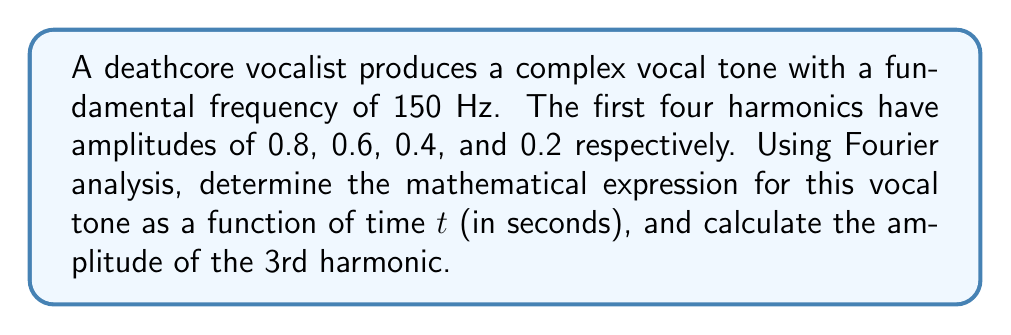Give your solution to this math problem. Let's approach this step-by-step:

1) In Fourier analysis, a complex tone can be represented as a sum of sine waves with different frequencies and amplitudes. The general form is:

   $$f(t) = \sum_{n=1}^{\infty} A_n \sin(2\pi n f_0 t)$$

   where $A_n$ is the amplitude of the nth harmonic, $f_0$ is the fundamental frequency, and $t$ is time.

2) We're given the fundamental frequency $f_0 = 150$ Hz and the amplitudes of the first four harmonics:
   
   $A_1 = 0.8$, $A_2 = 0.6$, $A_3 = 0.4$, $A_4 = 0.2$

3) Substituting these values into the general form:

   $$f(t) = 0.8 \sin(2\pi \cdot 150t) + 0.6 \sin(2\pi \cdot 300t) + 0.4 \sin(2\pi \cdot 450t) + 0.2 \sin(2\pi \cdot 600t)$$

4) This can be simplified to:

   $$f(t) = 0.8 \sin(300\pi t) + 0.6 \sin(600\pi t) + 0.4 \sin(900\pi t) + 0.2 \sin(1200\pi t)$$

5) The amplitude of the 3rd harmonic is directly given in the problem as 0.4.
Answer: $f(t) = 0.8 \sin(300\pi t) + 0.6 \sin(600\pi t) + 0.4 \sin(900\pi t) + 0.2 \sin(1200\pi t)$; 3rd harmonic amplitude = 0.4 